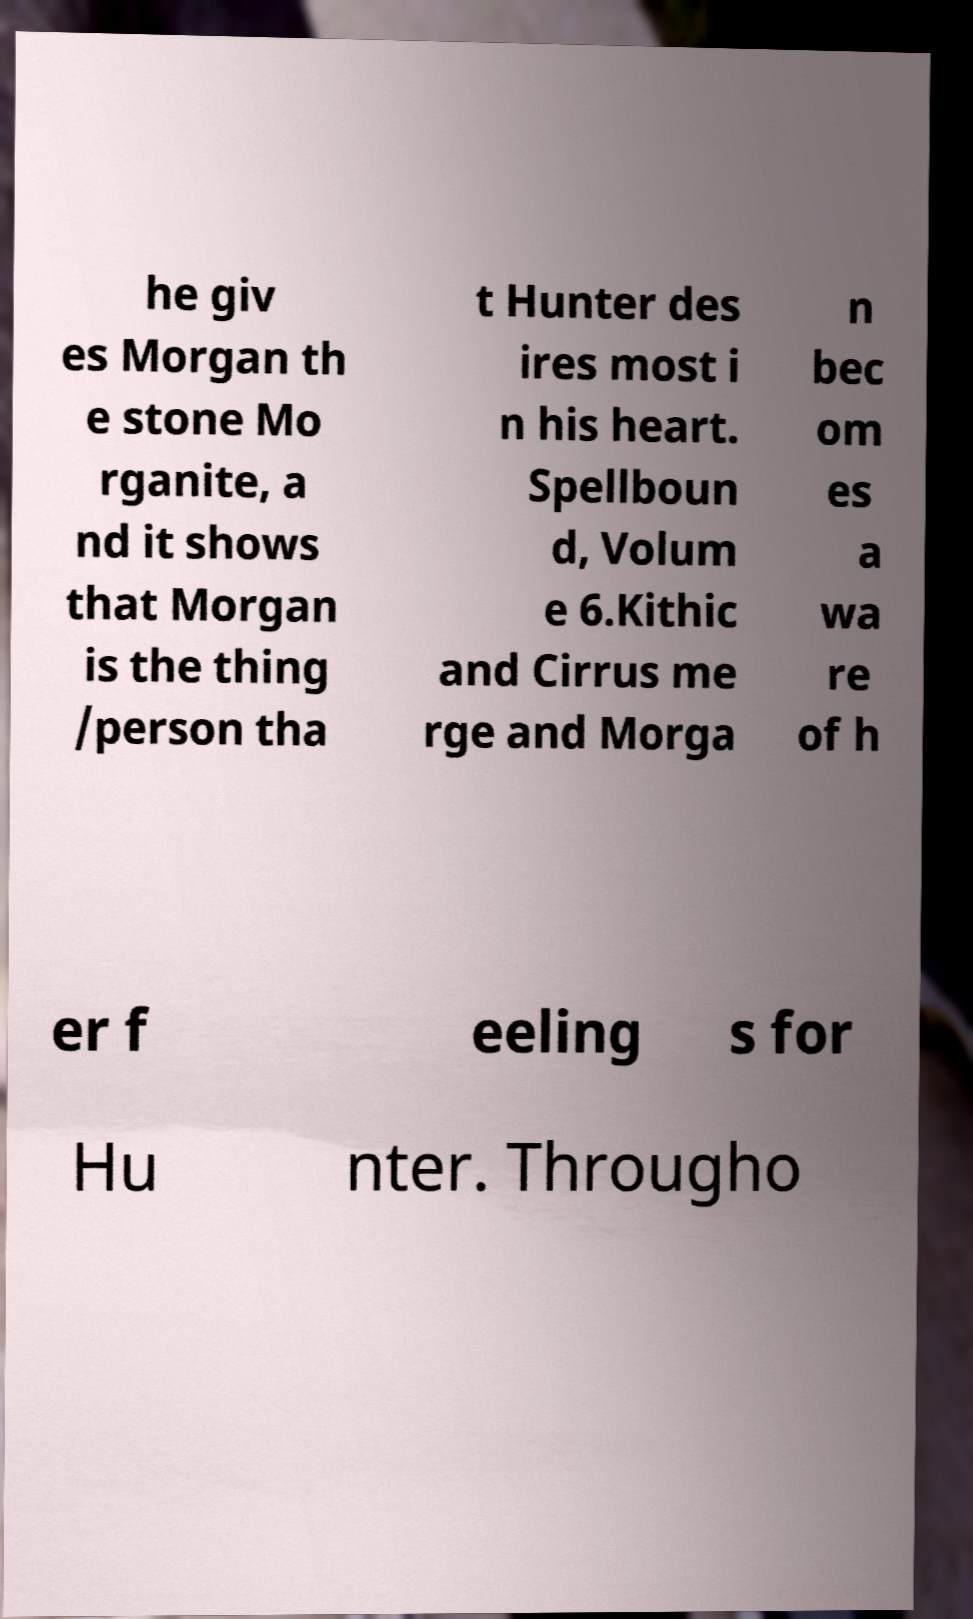Can you accurately transcribe the text from the provided image for me? he giv es Morgan th e stone Mo rganite, a nd it shows that Morgan is the thing /person tha t Hunter des ires most i n his heart. Spellboun d, Volum e 6.Kithic and Cirrus me rge and Morga n bec om es a wa re of h er f eeling s for Hu nter. Througho 